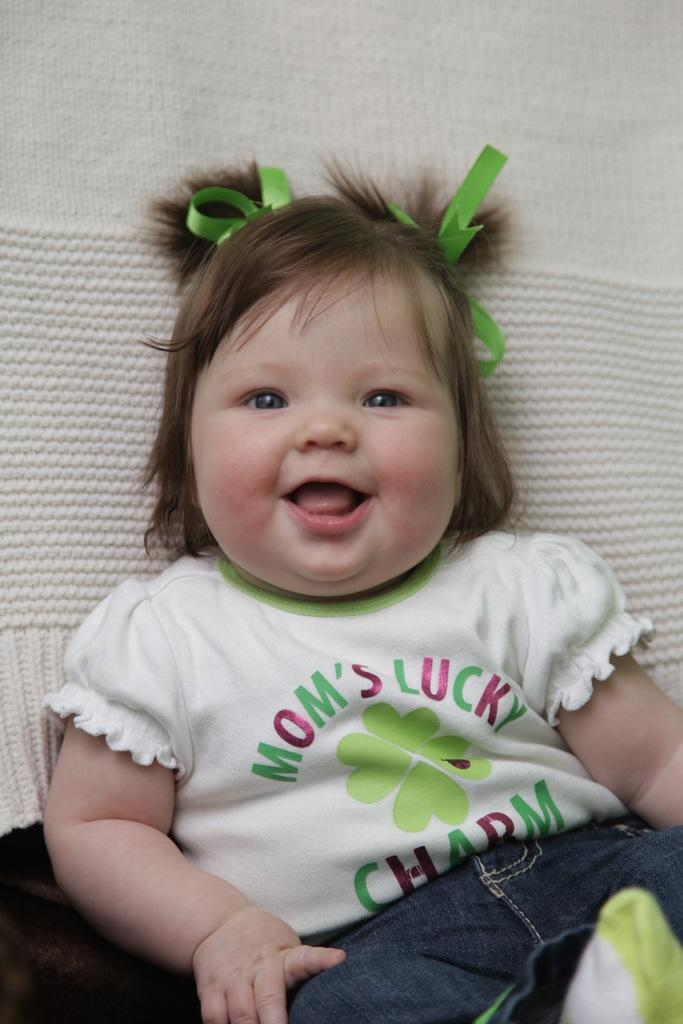What is the main subject of the image? There is a baby in the image. What is the baby wearing? The baby is wearing clothes. What can be seen in the background of the image? There is a cloth visible in the background of the image. How does the baby express disgust in the image? There is no indication of the baby expressing disgust in the image. 